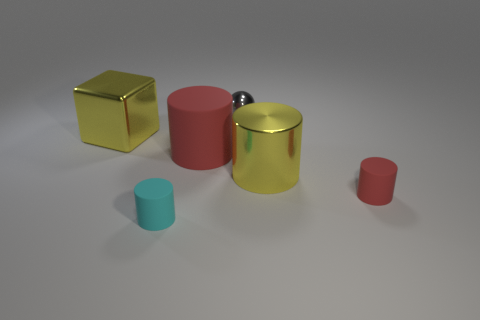Add 4 rubber things. How many objects exist? 10 Subtract all cylinders. How many objects are left? 2 Subtract all big brown matte cubes. Subtract all large red things. How many objects are left? 5 Add 3 small cyan matte cylinders. How many small cyan matte cylinders are left? 4 Add 1 small cylinders. How many small cylinders exist? 3 Subtract 1 yellow blocks. How many objects are left? 5 